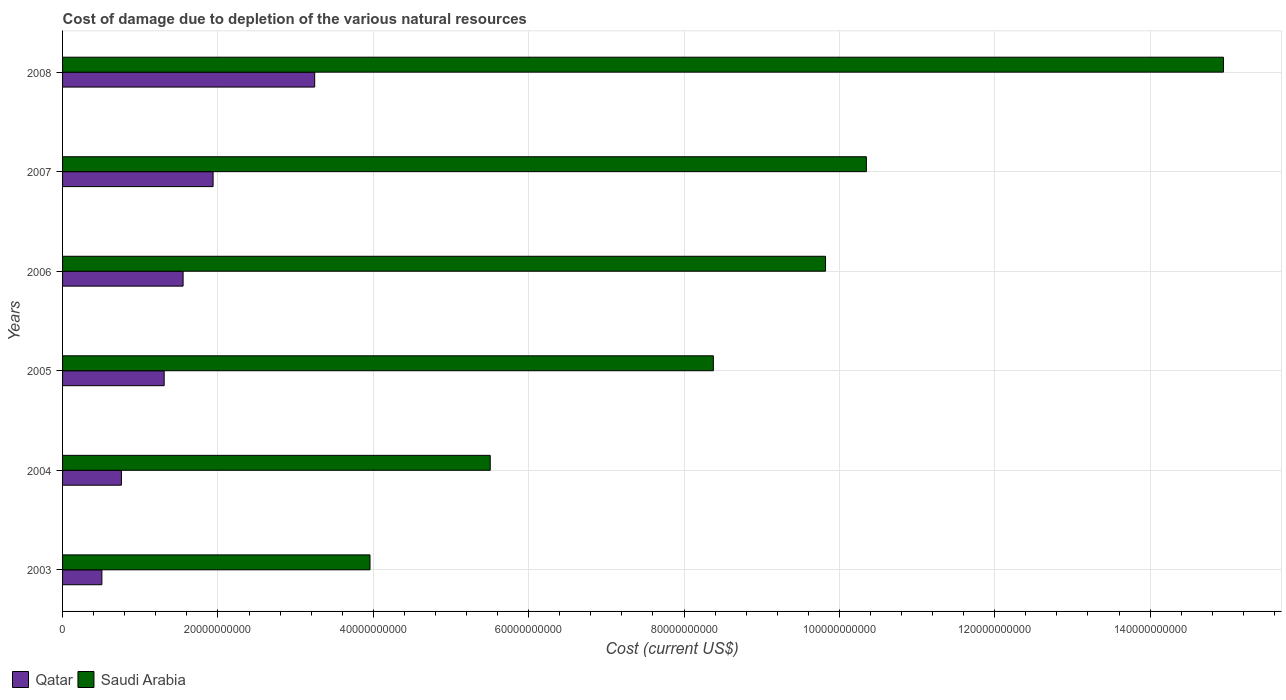How many different coloured bars are there?
Your response must be concise. 2. Are the number of bars on each tick of the Y-axis equal?
Offer a very short reply. Yes. What is the label of the 6th group of bars from the top?
Give a very brief answer. 2003. What is the cost of damage caused due to the depletion of various natural resources in Qatar in 2004?
Provide a short and direct response. 7.58e+09. Across all years, what is the maximum cost of damage caused due to the depletion of various natural resources in Qatar?
Provide a short and direct response. 3.25e+1. Across all years, what is the minimum cost of damage caused due to the depletion of various natural resources in Saudi Arabia?
Ensure brevity in your answer.  3.96e+1. In which year was the cost of damage caused due to the depletion of various natural resources in Saudi Arabia maximum?
Keep it short and to the point. 2008. In which year was the cost of damage caused due to the depletion of various natural resources in Qatar minimum?
Provide a succinct answer. 2003. What is the total cost of damage caused due to the depletion of various natural resources in Saudi Arabia in the graph?
Offer a terse response. 5.30e+11. What is the difference between the cost of damage caused due to the depletion of various natural resources in Qatar in 2004 and that in 2007?
Give a very brief answer. -1.18e+1. What is the difference between the cost of damage caused due to the depletion of various natural resources in Saudi Arabia in 2006 and the cost of damage caused due to the depletion of various natural resources in Qatar in 2003?
Keep it short and to the point. 9.32e+1. What is the average cost of damage caused due to the depletion of various natural resources in Saudi Arabia per year?
Your answer should be compact. 8.83e+1. In the year 2005, what is the difference between the cost of damage caused due to the depletion of various natural resources in Qatar and cost of damage caused due to the depletion of various natural resources in Saudi Arabia?
Provide a short and direct response. -7.07e+1. In how many years, is the cost of damage caused due to the depletion of various natural resources in Qatar greater than 108000000000 US$?
Your answer should be compact. 0. What is the ratio of the cost of damage caused due to the depletion of various natural resources in Saudi Arabia in 2005 to that in 2006?
Your answer should be very brief. 0.85. Is the cost of damage caused due to the depletion of various natural resources in Qatar in 2003 less than that in 2006?
Make the answer very short. Yes. What is the difference between the highest and the second highest cost of damage caused due to the depletion of various natural resources in Saudi Arabia?
Ensure brevity in your answer.  4.60e+1. What is the difference between the highest and the lowest cost of damage caused due to the depletion of various natural resources in Qatar?
Make the answer very short. 2.74e+1. In how many years, is the cost of damage caused due to the depletion of various natural resources in Saudi Arabia greater than the average cost of damage caused due to the depletion of various natural resources in Saudi Arabia taken over all years?
Give a very brief answer. 3. Is the sum of the cost of damage caused due to the depletion of various natural resources in Qatar in 2004 and 2006 greater than the maximum cost of damage caused due to the depletion of various natural resources in Saudi Arabia across all years?
Your response must be concise. No. What does the 1st bar from the top in 2008 represents?
Ensure brevity in your answer.  Saudi Arabia. What does the 2nd bar from the bottom in 2003 represents?
Your answer should be compact. Saudi Arabia. How many bars are there?
Keep it short and to the point. 12. How many years are there in the graph?
Your answer should be very brief. 6. Are the values on the major ticks of X-axis written in scientific E-notation?
Provide a succinct answer. No. How many legend labels are there?
Keep it short and to the point. 2. How are the legend labels stacked?
Your answer should be compact. Horizontal. What is the title of the graph?
Your answer should be compact. Cost of damage due to depletion of the various natural resources. Does "France" appear as one of the legend labels in the graph?
Give a very brief answer. No. What is the label or title of the X-axis?
Give a very brief answer. Cost (current US$). What is the Cost (current US$) of Qatar in 2003?
Your answer should be compact. 5.06e+09. What is the Cost (current US$) of Saudi Arabia in 2003?
Your answer should be compact. 3.96e+1. What is the Cost (current US$) in Qatar in 2004?
Provide a short and direct response. 7.58e+09. What is the Cost (current US$) of Saudi Arabia in 2004?
Your answer should be compact. 5.51e+1. What is the Cost (current US$) in Qatar in 2005?
Give a very brief answer. 1.31e+1. What is the Cost (current US$) of Saudi Arabia in 2005?
Ensure brevity in your answer.  8.38e+1. What is the Cost (current US$) of Qatar in 2006?
Your answer should be compact. 1.55e+1. What is the Cost (current US$) of Saudi Arabia in 2006?
Your response must be concise. 9.82e+1. What is the Cost (current US$) of Qatar in 2007?
Offer a very short reply. 1.94e+1. What is the Cost (current US$) in Saudi Arabia in 2007?
Ensure brevity in your answer.  1.03e+11. What is the Cost (current US$) of Qatar in 2008?
Keep it short and to the point. 3.25e+1. What is the Cost (current US$) in Saudi Arabia in 2008?
Offer a terse response. 1.49e+11. Across all years, what is the maximum Cost (current US$) in Qatar?
Your answer should be compact. 3.25e+1. Across all years, what is the maximum Cost (current US$) in Saudi Arabia?
Make the answer very short. 1.49e+11. Across all years, what is the minimum Cost (current US$) of Qatar?
Give a very brief answer. 5.06e+09. Across all years, what is the minimum Cost (current US$) of Saudi Arabia?
Your answer should be very brief. 3.96e+1. What is the total Cost (current US$) in Qatar in the graph?
Your answer should be very brief. 9.31e+1. What is the total Cost (current US$) in Saudi Arabia in the graph?
Provide a short and direct response. 5.30e+11. What is the difference between the Cost (current US$) of Qatar in 2003 and that in 2004?
Make the answer very short. -2.51e+09. What is the difference between the Cost (current US$) in Saudi Arabia in 2003 and that in 2004?
Offer a terse response. -1.55e+1. What is the difference between the Cost (current US$) of Qatar in 2003 and that in 2005?
Provide a succinct answer. -8.02e+09. What is the difference between the Cost (current US$) of Saudi Arabia in 2003 and that in 2005?
Keep it short and to the point. -4.42e+1. What is the difference between the Cost (current US$) in Qatar in 2003 and that in 2006?
Keep it short and to the point. -1.05e+1. What is the difference between the Cost (current US$) in Saudi Arabia in 2003 and that in 2006?
Your answer should be compact. -5.86e+1. What is the difference between the Cost (current US$) in Qatar in 2003 and that in 2007?
Your answer should be compact. -1.43e+1. What is the difference between the Cost (current US$) of Saudi Arabia in 2003 and that in 2007?
Offer a terse response. -6.39e+1. What is the difference between the Cost (current US$) of Qatar in 2003 and that in 2008?
Keep it short and to the point. -2.74e+1. What is the difference between the Cost (current US$) of Saudi Arabia in 2003 and that in 2008?
Your answer should be very brief. -1.10e+11. What is the difference between the Cost (current US$) of Qatar in 2004 and that in 2005?
Keep it short and to the point. -5.50e+09. What is the difference between the Cost (current US$) in Saudi Arabia in 2004 and that in 2005?
Provide a succinct answer. -2.87e+1. What is the difference between the Cost (current US$) of Qatar in 2004 and that in 2006?
Your answer should be compact. -7.94e+09. What is the difference between the Cost (current US$) in Saudi Arabia in 2004 and that in 2006?
Your response must be concise. -4.32e+1. What is the difference between the Cost (current US$) in Qatar in 2004 and that in 2007?
Your answer should be compact. -1.18e+1. What is the difference between the Cost (current US$) in Saudi Arabia in 2004 and that in 2007?
Ensure brevity in your answer.  -4.84e+1. What is the difference between the Cost (current US$) of Qatar in 2004 and that in 2008?
Your answer should be very brief. -2.49e+1. What is the difference between the Cost (current US$) of Saudi Arabia in 2004 and that in 2008?
Provide a short and direct response. -9.44e+1. What is the difference between the Cost (current US$) in Qatar in 2005 and that in 2006?
Make the answer very short. -2.44e+09. What is the difference between the Cost (current US$) in Saudi Arabia in 2005 and that in 2006?
Offer a very short reply. -1.44e+1. What is the difference between the Cost (current US$) of Qatar in 2005 and that in 2007?
Make the answer very short. -6.30e+09. What is the difference between the Cost (current US$) in Saudi Arabia in 2005 and that in 2007?
Provide a short and direct response. -1.97e+1. What is the difference between the Cost (current US$) of Qatar in 2005 and that in 2008?
Make the answer very short. -1.94e+1. What is the difference between the Cost (current US$) of Saudi Arabia in 2005 and that in 2008?
Offer a terse response. -6.57e+1. What is the difference between the Cost (current US$) in Qatar in 2006 and that in 2007?
Your answer should be compact. -3.86e+09. What is the difference between the Cost (current US$) in Saudi Arabia in 2006 and that in 2007?
Give a very brief answer. -5.26e+09. What is the difference between the Cost (current US$) in Qatar in 2006 and that in 2008?
Keep it short and to the point. -1.69e+1. What is the difference between the Cost (current US$) in Saudi Arabia in 2006 and that in 2008?
Your response must be concise. -5.12e+1. What is the difference between the Cost (current US$) of Qatar in 2007 and that in 2008?
Your answer should be very brief. -1.31e+1. What is the difference between the Cost (current US$) in Saudi Arabia in 2007 and that in 2008?
Your answer should be compact. -4.60e+1. What is the difference between the Cost (current US$) in Qatar in 2003 and the Cost (current US$) in Saudi Arabia in 2004?
Make the answer very short. -5.00e+1. What is the difference between the Cost (current US$) in Qatar in 2003 and the Cost (current US$) in Saudi Arabia in 2005?
Provide a short and direct response. -7.87e+1. What is the difference between the Cost (current US$) in Qatar in 2003 and the Cost (current US$) in Saudi Arabia in 2006?
Offer a terse response. -9.32e+1. What is the difference between the Cost (current US$) of Qatar in 2003 and the Cost (current US$) of Saudi Arabia in 2007?
Ensure brevity in your answer.  -9.84e+1. What is the difference between the Cost (current US$) in Qatar in 2003 and the Cost (current US$) in Saudi Arabia in 2008?
Offer a very short reply. -1.44e+11. What is the difference between the Cost (current US$) of Qatar in 2004 and the Cost (current US$) of Saudi Arabia in 2005?
Offer a very short reply. -7.62e+1. What is the difference between the Cost (current US$) in Qatar in 2004 and the Cost (current US$) in Saudi Arabia in 2006?
Make the answer very short. -9.06e+1. What is the difference between the Cost (current US$) of Qatar in 2004 and the Cost (current US$) of Saudi Arabia in 2007?
Your response must be concise. -9.59e+1. What is the difference between the Cost (current US$) in Qatar in 2004 and the Cost (current US$) in Saudi Arabia in 2008?
Your answer should be very brief. -1.42e+11. What is the difference between the Cost (current US$) in Qatar in 2005 and the Cost (current US$) in Saudi Arabia in 2006?
Provide a short and direct response. -8.51e+1. What is the difference between the Cost (current US$) of Qatar in 2005 and the Cost (current US$) of Saudi Arabia in 2007?
Make the answer very short. -9.04e+1. What is the difference between the Cost (current US$) in Qatar in 2005 and the Cost (current US$) in Saudi Arabia in 2008?
Offer a very short reply. -1.36e+11. What is the difference between the Cost (current US$) in Qatar in 2006 and the Cost (current US$) in Saudi Arabia in 2007?
Provide a succinct answer. -8.80e+1. What is the difference between the Cost (current US$) of Qatar in 2006 and the Cost (current US$) of Saudi Arabia in 2008?
Make the answer very short. -1.34e+11. What is the difference between the Cost (current US$) in Qatar in 2007 and the Cost (current US$) in Saudi Arabia in 2008?
Your response must be concise. -1.30e+11. What is the average Cost (current US$) of Qatar per year?
Make the answer very short. 1.55e+1. What is the average Cost (current US$) in Saudi Arabia per year?
Ensure brevity in your answer.  8.83e+1. In the year 2003, what is the difference between the Cost (current US$) in Qatar and Cost (current US$) in Saudi Arabia?
Offer a very short reply. -3.45e+1. In the year 2004, what is the difference between the Cost (current US$) of Qatar and Cost (current US$) of Saudi Arabia?
Make the answer very short. -4.75e+1. In the year 2005, what is the difference between the Cost (current US$) of Qatar and Cost (current US$) of Saudi Arabia?
Offer a terse response. -7.07e+1. In the year 2006, what is the difference between the Cost (current US$) of Qatar and Cost (current US$) of Saudi Arabia?
Offer a very short reply. -8.27e+1. In the year 2007, what is the difference between the Cost (current US$) of Qatar and Cost (current US$) of Saudi Arabia?
Ensure brevity in your answer.  -8.41e+1. In the year 2008, what is the difference between the Cost (current US$) in Qatar and Cost (current US$) in Saudi Arabia?
Provide a succinct answer. -1.17e+11. What is the ratio of the Cost (current US$) in Qatar in 2003 to that in 2004?
Keep it short and to the point. 0.67. What is the ratio of the Cost (current US$) in Saudi Arabia in 2003 to that in 2004?
Provide a short and direct response. 0.72. What is the ratio of the Cost (current US$) of Qatar in 2003 to that in 2005?
Give a very brief answer. 0.39. What is the ratio of the Cost (current US$) of Saudi Arabia in 2003 to that in 2005?
Make the answer very short. 0.47. What is the ratio of the Cost (current US$) of Qatar in 2003 to that in 2006?
Provide a short and direct response. 0.33. What is the ratio of the Cost (current US$) of Saudi Arabia in 2003 to that in 2006?
Your answer should be very brief. 0.4. What is the ratio of the Cost (current US$) in Qatar in 2003 to that in 2007?
Your answer should be very brief. 0.26. What is the ratio of the Cost (current US$) of Saudi Arabia in 2003 to that in 2007?
Provide a succinct answer. 0.38. What is the ratio of the Cost (current US$) in Qatar in 2003 to that in 2008?
Keep it short and to the point. 0.16. What is the ratio of the Cost (current US$) in Saudi Arabia in 2003 to that in 2008?
Provide a short and direct response. 0.26. What is the ratio of the Cost (current US$) of Qatar in 2004 to that in 2005?
Provide a succinct answer. 0.58. What is the ratio of the Cost (current US$) in Saudi Arabia in 2004 to that in 2005?
Your answer should be compact. 0.66. What is the ratio of the Cost (current US$) of Qatar in 2004 to that in 2006?
Ensure brevity in your answer.  0.49. What is the ratio of the Cost (current US$) of Saudi Arabia in 2004 to that in 2006?
Your answer should be compact. 0.56. What is the ratio of the Cost (current US$) in Qatar in 2004 to that in 2007?
Give a very brief answer. 0.39. What is the ratio of the Cost (current US$) in Saudi Arabia in 2004 to that in 2007?
Offer a very short reply. 0.53. What is the ratio of the Cost (current US$) in Qatar in 2004 to that in 2008?
Make the answer very short. 0.23. What is the ratio of the Cost (current US$) in Saudi Arabia in 2004 to that in 2008?
Keep it short and to the point. 0.37. What is the ratio of the Cost (current US$) of Qatar in 2005 to that in 2006?
Provide a short and direct response. 0.84. What is the ratio of the Cost (current US$) of Saudi Arabia in 2005 to that in 2006?
Provide a short and direct response. 0.85. What is the ratio of the Cost (current US$) in Qatar in 2005 to that in 2007?
Ensure brevity in your answer.  0.68. What is the ratio of the Cost (current US$) of Saudi Arabia in 2005 to that in 2007?
Offer a terse response. 0.81. What is the ratio of the Cost (current US$) in Qatar in 2005 to that in 2008?
Your response must be concise. 0.4. What is the ratio of the Cost (current US$) of Saudi Arabia in 2005 to that in 2008?
Your response must be concise. 0.56. What is the ratio of the Cost (current US$) in Qatar in 2006 to that in 2007?
Your response must be concise. 0.8. What is the ratio of the Cost (current US$) of Saudi Arabia in 2006 to that in 2007?
Your answer should be compact. 0.95. What is the ratio of the Cost (current US$) in Qatar in 2006 to that in 2008?
Offer a very short reply. 0.48. What is the ratio of the Cost (current US$) of Saudi Arabia in 2006 to that in 2008?
Provide a succinct answer. 0.66. What is the ratio of the Cost (current US$) of Qatar in 2007 to that in 2008?
Ensure brevity in your answer.  0.6. What is the ratio of the Cost (current US$) in Saudi Arabia in 2007 to that in 2008?
Keep it short and to the point. 0.69. What is the difference between the highest and the second highest Cost (current US$) in Qatar?
Your answer should be compact. 1.31e+1. What is the difference between the highest and the second highest Cost (current US$) in Saudi Arabia?
Your response must be concise. 4.60e+1. What is the difference between the highest and the lowest Cost (current US$) in Qatar?
Offer a very short reply. 2.74e+1. What is the difference between the highest and the lowest Cost (current US$) of Saudi Arabia?
Your answer should be compact. 1.10e+11. 